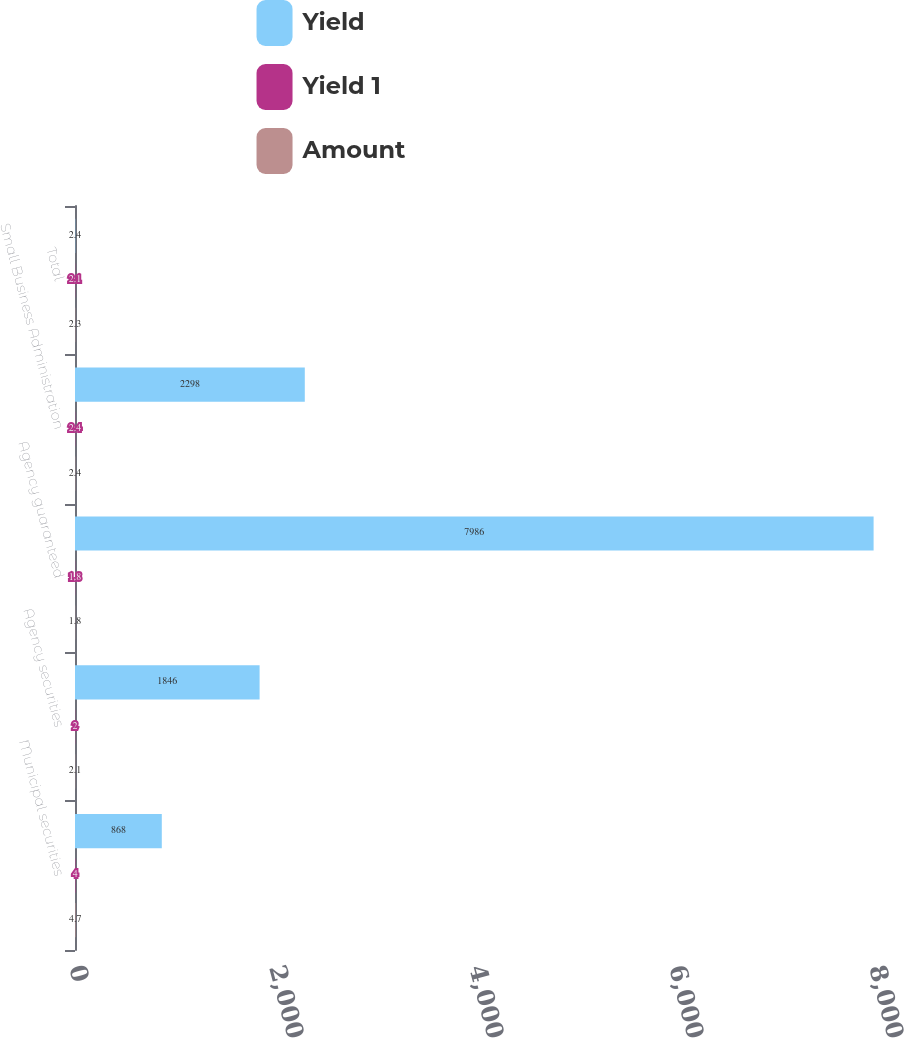Convert chart to OTSL. <chart><loc_0><loc_0><loc_500><loc_500><stacked_bar_chart><ecel><fcel>Municipal securities<fcel>Agency securities<fcel>Agency guaranteed<fcel>Small Business Administration<fcel>Total<nl><fcel>Yield<fcel>868<fcel>1846<fcel>7986<fcel>2298<fcel>2.4<nl><fcel>Yield 1<fcel>4<fcel>2<fcel>1.8<fcel>2.4<fcel>2.1<nl><fcel>Amount<fcel>4.7<fcel>2.1<fcel>1.8<fcel>2.4<fcel>2.3<nl></chart> 